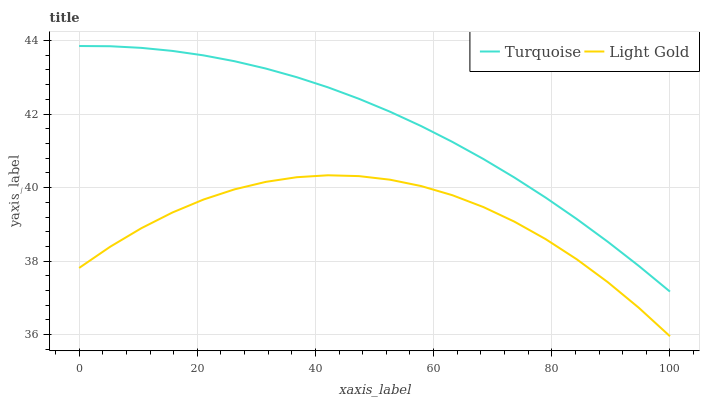Does Light Gold have the minimum area under the curve?
Answer yes or no. Yes. Does Turquoise have the maximum area under the curve?
Answer yes or no. Yes. Does Light Gold have the maximum area under the curve?
Answer yes or no. No. Is Turquoise the smoothest?
Answer yes or no. Yes. Is Light Gold the roughest?
Answer yes or no. Yes. Is Light Gold the smoothest?
Answer yes or no. No. Does Light Gold have the lowest value?
Answer yes or no. Yes. Does Turquoise have the highest value?
Answer yes or no. Yes. Does Light Gold have the highest value?
Answer yes or no. No. Is Light Gold less than Turquoise?
Answer yes or no. Yes. Is Turquoise greater than Light Gold?
Answer yes or no. Yes. Does Light Gold intersect Turquoise?
Answer yes or no. No. 